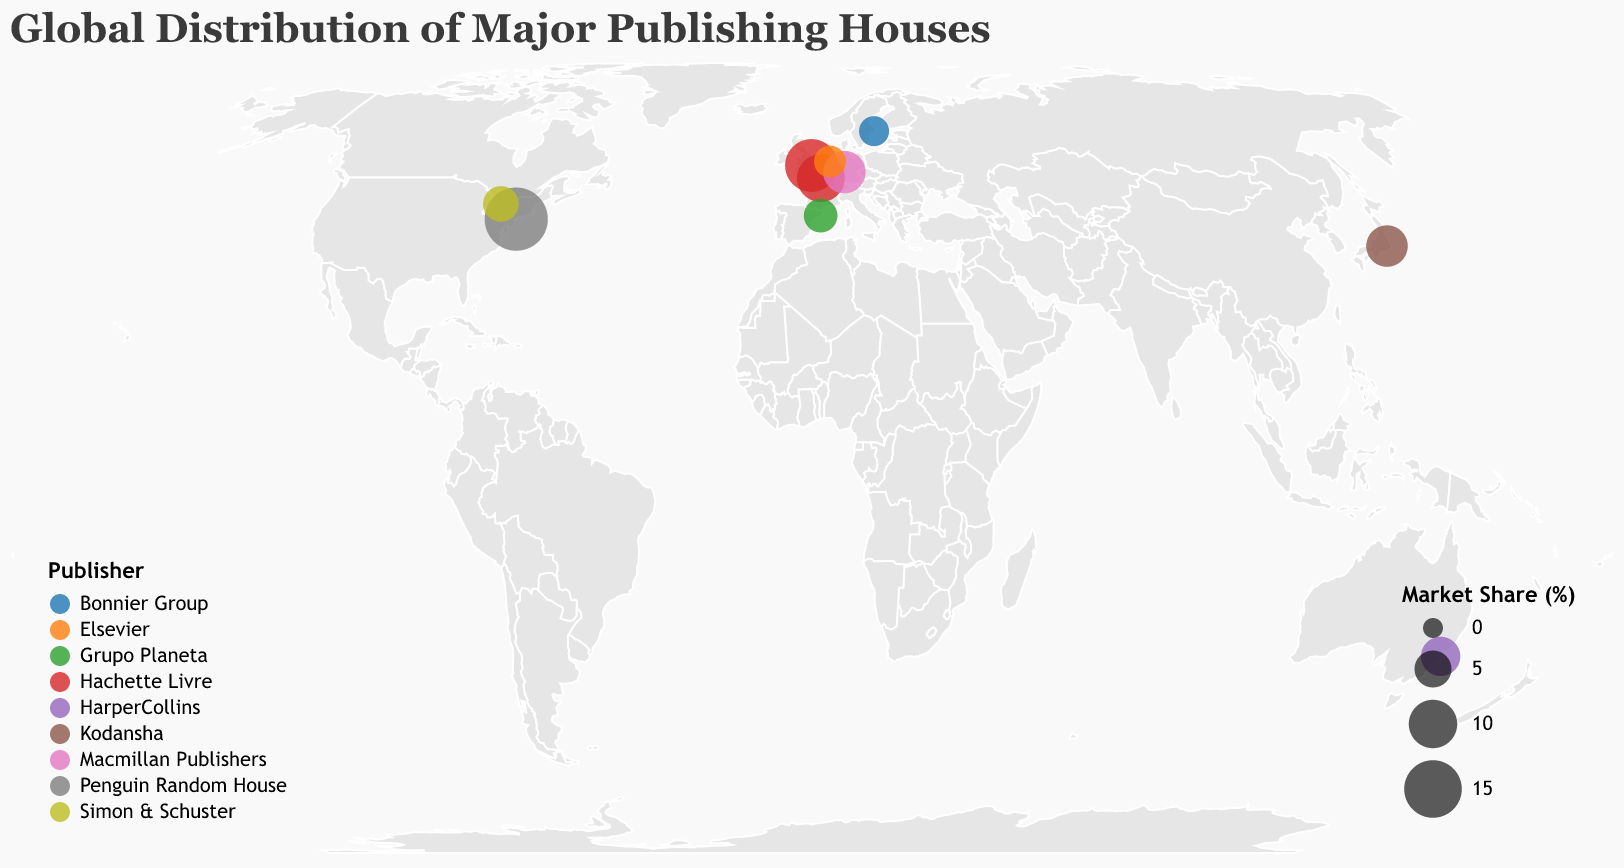What is the title of the figure? The title is displayed at the top of the figure in larger font size and different style compared to other text elements.
Answer: Global Distribution of Major Publishing Houses Which city has the highest market share of publishing houses? By inspecting the size of circles representing market share, New York has the largest circle visible on the plot.
Answer: New York What is the market share of the subsidiary located in London? By hovering over the circle at the London location, the tooltip shows the market share value.
Answer: 12.3% How many cities are represented in the figure? By counting the unique circles on the map, each representing a different city, we can see there are 10 cities.
Answer: 10 What is the common attribute used to color the circles on the map? The legend at the bottom-left corner uses different colors to indicate the publishers.
Answer: Publisher Which publishing house has subsidiaries in both Paris and London? Inspecting the tooltip by hovering over the circles in Paris and London reveals that Hachette Livre is the common publishing house.
Answer: Hachette Livre What is the total market share of the subsidiaries in Europe? Summing the market share values of subsidiaries located in London, Paris, Frankfurt, Barcelona, Amsterdam, and Stockholm: 12.3 + 9.7 + 7.2 + 3.8 + 3.2 + 2.6 = 38.8
Answer: 38.8% What publishing house is associated with the subsidiary in Tokyo? Hovering over the circle at the Tokyo location shows the tooltip with the publisher information.
Answer: Kodansha Compare the market shares of the publishing house subsidiaries in North America. By comparing the sizes of the circles in New York (18.5%) and Toronto (4.5%), it is clear that New York has a higher market share than Toronto.
Answer: New York > Toronto 